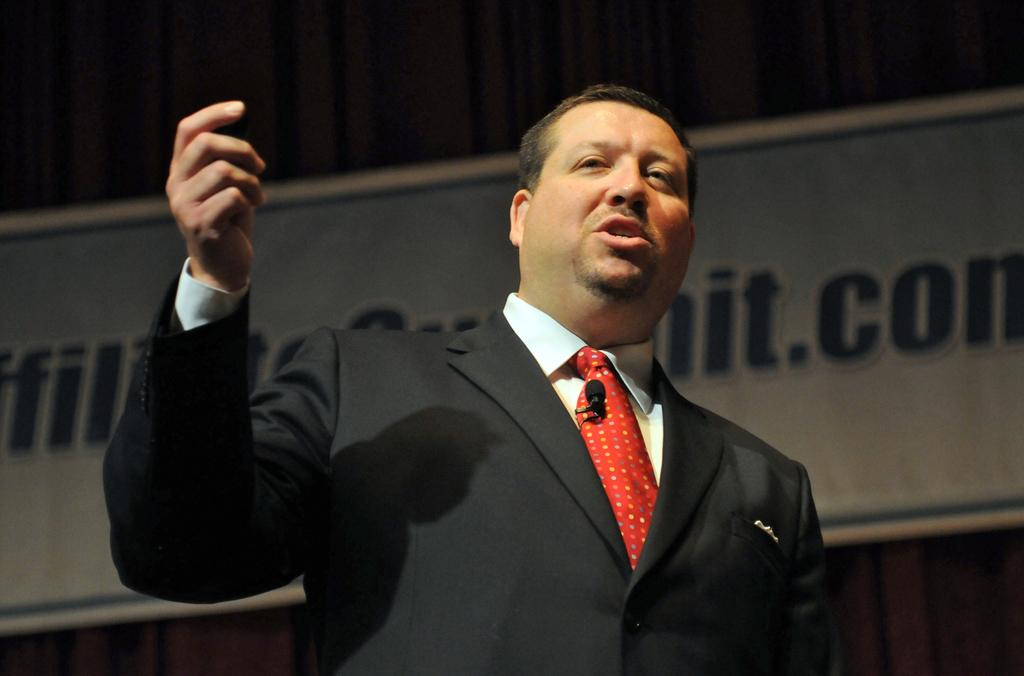Who is present in the image? There is a man in the image. What is the man wearing? The man is wearing a black suit and a red tie. What is the man doing in the image? The man is talking. What can be seen on the wall in the background of the image? There is a board on the wall in the background of the image. What is the man's brother's reaction to the news in the image? There is no information about the man's brother or any news in the image, so it is not possible to answer this question. 